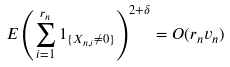Convert formula to latex. <formula><loc_0><loc_0><loc_500><loc_500>E \left ( \sum _ { i = 1 } ^ { r _ { n } } { 1 _ { \{ X _ { n , i } \ne 0 \} } } \right ) ^ { 2 + \delta } = O ( r _ { n } v _ { n } )</formula> 